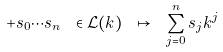Convert formula to latex. <formula><loc_0><loc_0><loc_500><loc_500>+ s _ { 0 } \cdots s _ { n } \ \in \mathcal { L } ( k ) \ \mapsto \ \sum _ { j = 0 } ^ { n } s _ { j } k ^ { j }</formula> 